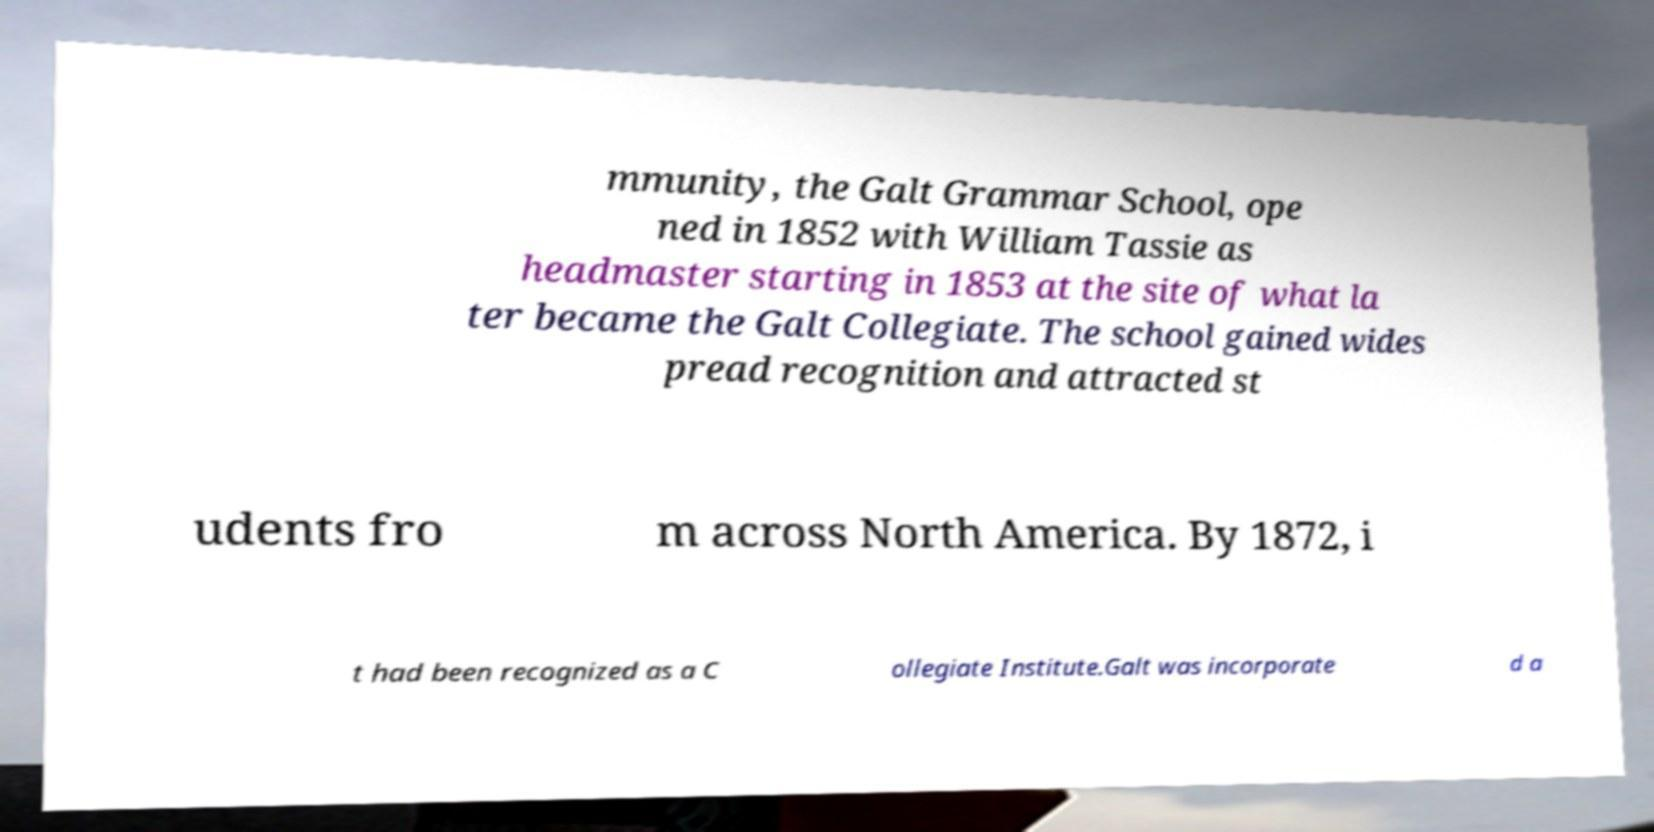Please read and relay the text visible in this image. What does it say? mmunity, the Galt Grammar School, ope ned in 1852 with William Tassie as headmaster starting in 1853 at the site of what la ter became the Galt Collegiate. The school gained wides pread recognition and attracted st udents fro m across North America. By 1872, i t had been recognized as a C ollegiate Institute.Galt was incorporate d a 